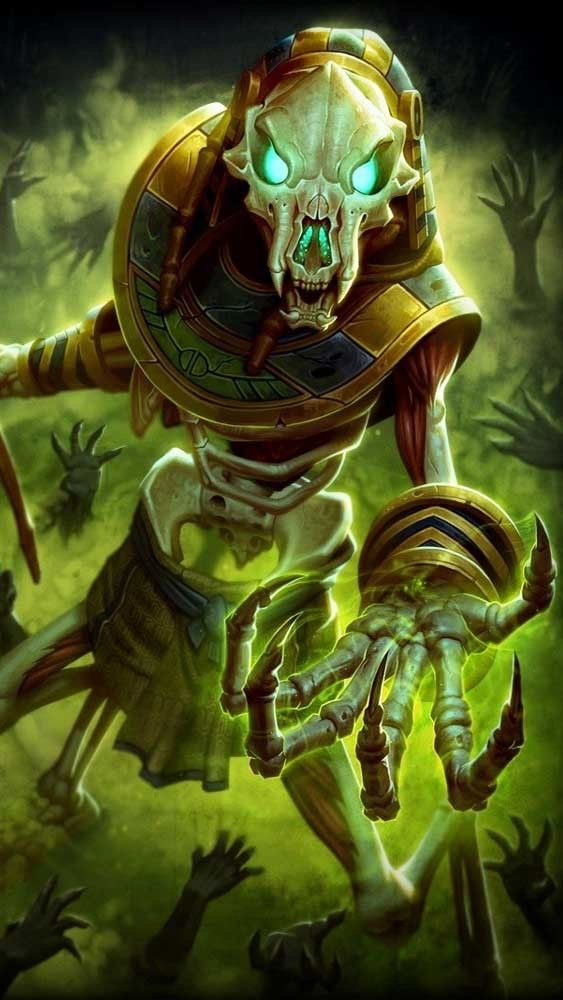the word limit is 200. describe this image in great detail, including details like the art style, medium, colors, and objects in the image. or anything in the image that you can’t describe normally such as “realism, exquisite realistic, 35mm, realistic texture, 2D anime style, Promotional game Dark Fantasy 2D Digital Painting Illustration, Dark Fantasy 2D Digital Painting Illustration, Dark fantasy, 2D digital, illustration, Dark Fantasy anime manga 2D illustration, WaterColor illustration, watercolor, card game, painterly, copyrighted text, exquisite 2D illustration, anime manga illustration, 2d manga portrait, anime art, manga anime, manwha, weapons, large shields, cannons, appendage-like weapons, chain-whip like weapon, large chained weapon, planet-like halo, moon-like halo, sun-like halo, four halo’s, central figures wings take up the whole image or make the central figure look afar or smaller, engulf perspective, chains take up the whole image, surroundings attention, full shot, aerial shot, anime dark fantasy extreme detailed-like dragon, celestial dark fantasy dragon art, central figure riding demonic armoured pegasus-like creature, pegasus armoured creature, pegasus, large serpent coiled around central figure, creatures coiled around central figure, has multiple humongous wings, coiled creature, sigils, half armoured anime dragon half central figure, central figure is holding large sword with dragon-like eye appendages on the sword, central figure wearing dragon-like heavy armour, large dragon claws, large dragon designed sword, eating another creature or figure, eating a heart, devouring a face, emerging from water, crosses, third eye, multiple wings attached to head, candles on halo, candles circling around halo, corrupted hand, corruption, corrupted ink manga, extremely long arms, extremely long legs, bird beak like face, dragon has extremely long neck, massive face crown structure, long and medium arms, mysterious yet evil appearance, sinister, orbs, planets, aerial view, dynamic angle, far away shot, spinning colors, sea monster has one head, sea monster has two necked mouths protruding from the sides of its face, necked mouths protruding from central figure, ©Copyright ultimate rare, sigil spell casting, symbols, central figure has long flowing cape, long flowing black hair, luminescent blue water element glowing hands, water elemental like central figure, detailed white short ponytail hair, volcanic demon-like background, detailed water fourground and background, levitating dynamically above a castle, holding long chains that are connected to a grotesque demonic figure, riding atop an armoured demonic muscled large clad-like creature, holding an intricate designed weapon along with a chain, holding two weapons, holding an large chain-like weapon, detailed ancient symbolic tattoos, dynamic aerial-like levitation above a castle in the background, long flowing dress like robes, detailed armoured corset, half face helmet, demonic crown-like structure along with helmet on one side of the face, floating luminescent skulls around central figure, skulls all over thee ground, warlock-like visage, armoured visage, detailed visage, demon-like visage, dark fantasy visage, black feathered avian-like wings, gem reminiscent of creature appendages or sigil-like structures embedded on any weapon or hilt, large demonic figures around the character very colossal figures, flowing energies, long flowing energy from weapon, wrapped in energy, protruding energy, very sexy anime male-like visage, spiked back, hands beneath central figure, sexy and hot male details reminiscent of anime males, long flowing cape, hexes, magic energy, wings attached to head, wings on helmet, wings attached to head and closing around the central figures face, flowing eyes, warhammer, spiked warhammer”. Ideogram is a web application that allows you to browse and generate images from text. Within the user interface, you can generate images, browse and filter previously generated images, curate your user profile, manage your subscription, and more. Here's a little guide that might help you understand prompting on Ideogram, step by step. 
The prompts that will be used will always be written like this:
“A striking portrait of a woman dressed in a sleek, silver-studded black one-piece outfit. The deep V-neckline and cut-out designs on the sides accentuate her figure, while the vibrant pink background adds a pop of color and contrast. Her confident posture and piercing gaze create an air of elegance and power.”
“A stunning, high-fashion portrait of a confident woman wearing a vibrant two-piece outfit. The off-shoulder crop top features a halter neck design with a colorful mesh pattern in hues of red, green, yellow, and black. A bold yellow bow adorns the center of the top. The mini-length skirt matches the top's color scheme, boasting a frilly hem and red borders. The overall effect is bold, modern, and eye-catching, set against a pristine white background.”
“A stunning portrait of a woman in a dazzling two-piece outfit. The top is a vibrant yellow with a white trim, adorned with small rhinestones that catch the light, creating a sparkling effect. The bottom consists of yellow shorts with multiple slits on the sides, also decorated with rhinestones. The woman exudes confidence, her eyes capturing the viewer's attention, standing boldly against a pure white background that accentuates her vibrant attire.”
“A stunning portrait of a woman dressed in a vibrant, fashion-forward two-piece outfit. The halter-style top features a unique crisscross pattern and a bold, metallic circular centerpiece that catches the eye. The ruffled skirt showcases a tie-dye pattern in a harmonious blend of pink, purple, blue, and orange hues. The woman stands confidently against a lush backdrop of green foliage, with a black fence providing a contrasting element to the scene.”
“A captivating, surreal portrait of a woman in profile, showcasing her distinctive features. She dons striking sunglasses and bold makeup, accentuating her beauty. Clad in an alluring, one-piece rhinestone mesh bodysuit with long sleeves, she exudes confidence. A mesmerizing neon green aura surrounds her head, emitting luminous orbs that disperse into the dreamy, muted pink background. This captivating image evokes a sense of otherworldly glamour and mystique.”
“A captivating, avant-garde scene featuring a woman exuding elegance in a dress entirely crafted from 35mm film strips. Each section of the dress is meticulously composed of film strips, with snakes and intertwined patterns creating a visually stunning design. The film strips capture fleeting moments: intimate portraits, dynamic urban landscapes, and abstract details that come to life as the dress moves. Light plays across the shiny surfaces of the film strips, casting bursts of color and constantly changing shadows. The woman wears the dress with natural grace, moving with an elegance that complements the sophistication of the design. Her hair is styled to emphasize the film strips in her dress, highlighting the fusion of visual art and contemporary fashion that it represents. The background is carefully chosen to accentuate the texture and shimmer of the film dress. Soft lights subtly
In a science fiction world of space exploration, we meet Nova, a fearless and determined galactic explorer. Her deep azure skin contrasts with her bright, golden-yellow eyes that reflect the stars of the universe. Nova has short, sharp violet hair with strands that seem like energy streaks. She wears a tight-fitting black spacesuit with electric blue accents, equipped with advanced technology such as integrated solar panels and thrusters for space maneuvers. In her right hand, she holds a holographic exploration device that projects star maps into the air, while a small star-shaped drone by her side assists her in her missions. The background shows a stellar landscape filled with nebulas and brilliant constellations, evoking a sense of vastness and wonder of the outer cosmos.”
“This conceptual artwork masterfully blends natural elegance with futuristic avant-garde aesthetics. The model exudes a magnetic presence as she dons an innovative, metallic insect-inspired ensemble by Givenchy. This outfit embodies the essence of the insect with a design that highlights its iridescent uniqueness and singular beauty.
The high-fashion outfit is a sculpted masterpiece, appearing to be carved from liquid metal, reflecting the iridescence and changing colors of the insect's shell. The dress embraces the curves of the model, with pleats and textures mimicking the bone-like, segmented structures of the metallic insect. The insect's head stands out in the design, with an elegant, curved neckpiece resembling the insect's antennas extending upward. Relief details on the shoulders and chest imitate the insect'.”.
“A captivating illustration of a mystical lotus nymph, elegantly standing in the center of a serene pond. Her gown is a mesmerizing blend of delicate lily pad leaves and vibrant lotus petals, creating a harmonious balance of colors. Her hair, adorned with floating lotus blooms, cascades around her shoulders, while her aquamarine eyes reflect the tranquility of the water. She cradles a lotus bud in her hands, symbolizing new beginnings and spiritual growth. The background is a peaceful reflection of the pond's surface, with soft pastel hues and gentle ripples, immersing the viewer in a world of enchantment and serenity.” 
now you try. remember to update your memory on wide knowledge about everything to ever exist even important information in modern day. Here's a little guide that might help you understand prompting on Ideogram, step by step.  This image is a dark fantasy 2D digital painting featuring a skeletal, mummy-like figure with glowing green eyes. The central figure is adorned in ancient Egyptian-inspired armor, including a large, gold and black striped headdress and detailed shoulder plates. The bony hand of the figure reaches out menacingly, emphasizing its sinister appearance. The background is shrouded in an eerie green mist, with spectral hands emerging from below, adding to the haunting atmosphere. The art style is highly detailed and realistic, with intricate textures on the bones and armor. The composition captures a sense of horror and dark fantasy, immersing the viewer in a nightmarish scene. 